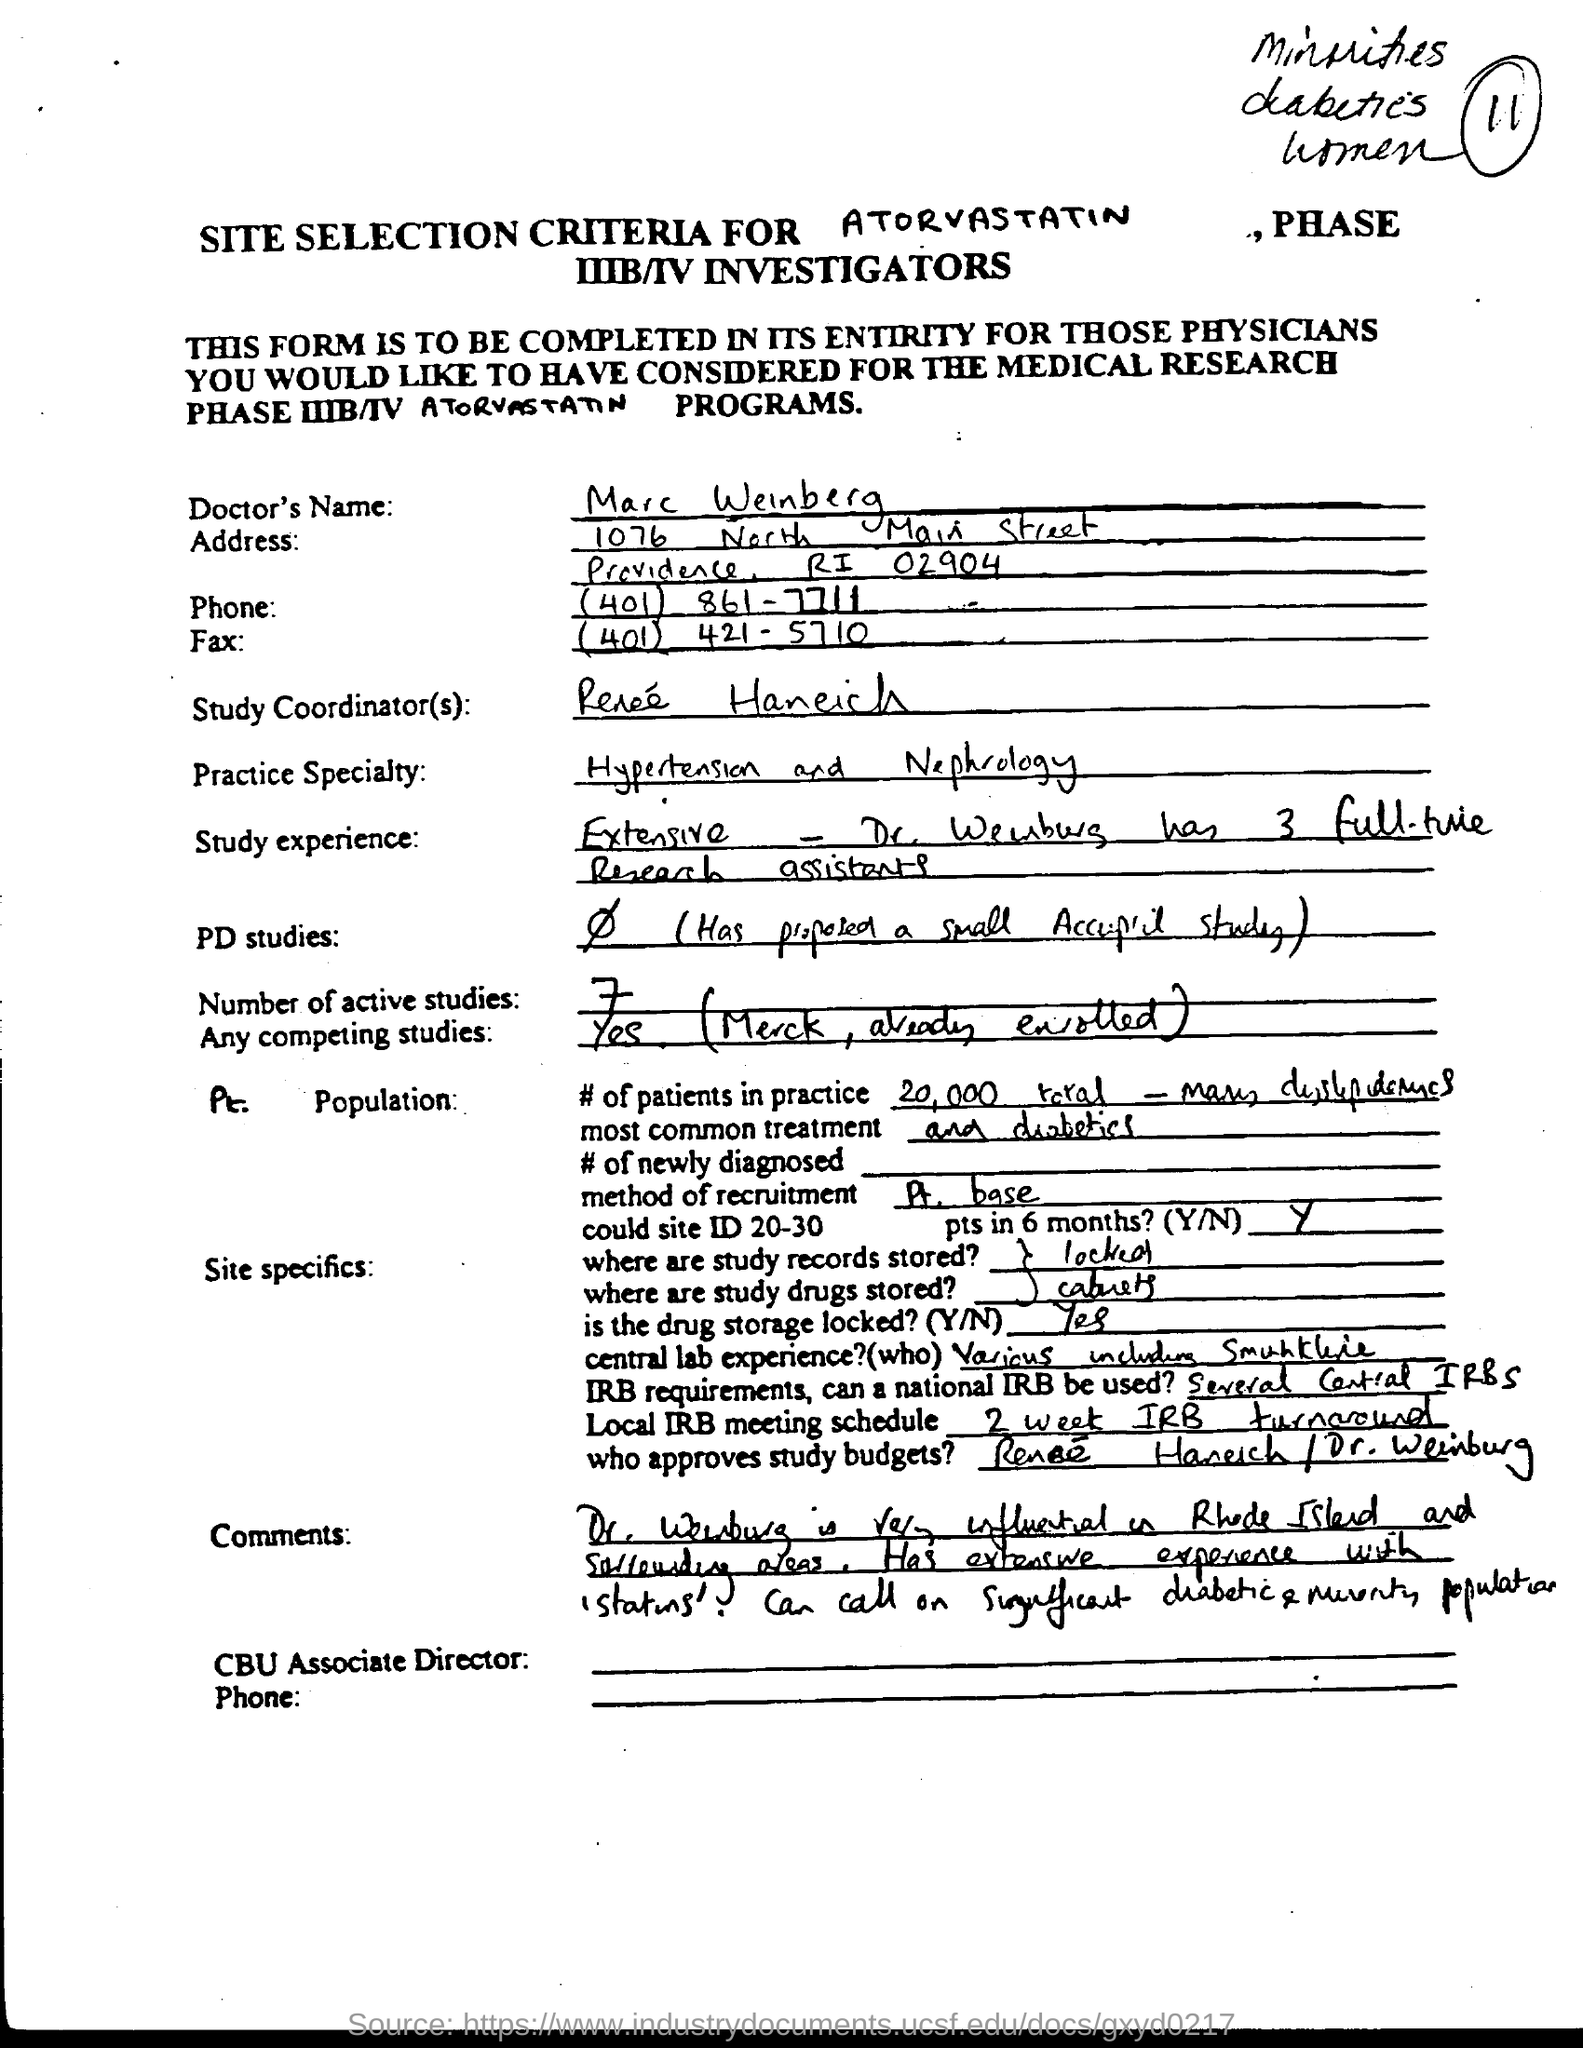What is the Doctor's Name?
Keep it short and to the point. Marc Weinberg. What are the number of active studies?
Offer a terse response. 7. What is the practice specialty of the Doctor's?
Keep it short and to the point. Hypertension and nephrology. 